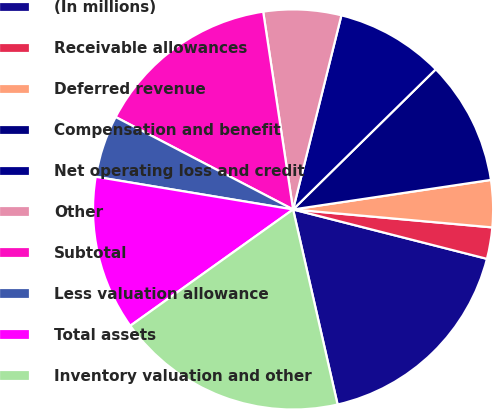<chart> <loc_0><loc_0><loc_500><loc_500><pie_chart><fcel>(In millions)<fcel>Receivable allowances<fcel>Deferred revenue<fcel>Compensation and benefit<fcel>Net operating loss and credit<fcel>Other<fcel>Subtotal<fcel>Less valuation allowance<fcel>Total assets<fcel>Inventory valuation and other<nl><fcel>17.46%<fcel>2.54%<fcel>3.79%<fcel>10.0%<fcel>8.76%<fcel>6.27%<fcel>14.97%<fcel>5.03%<fcel>12.49%<fcel>18.7%<nl></chart> 